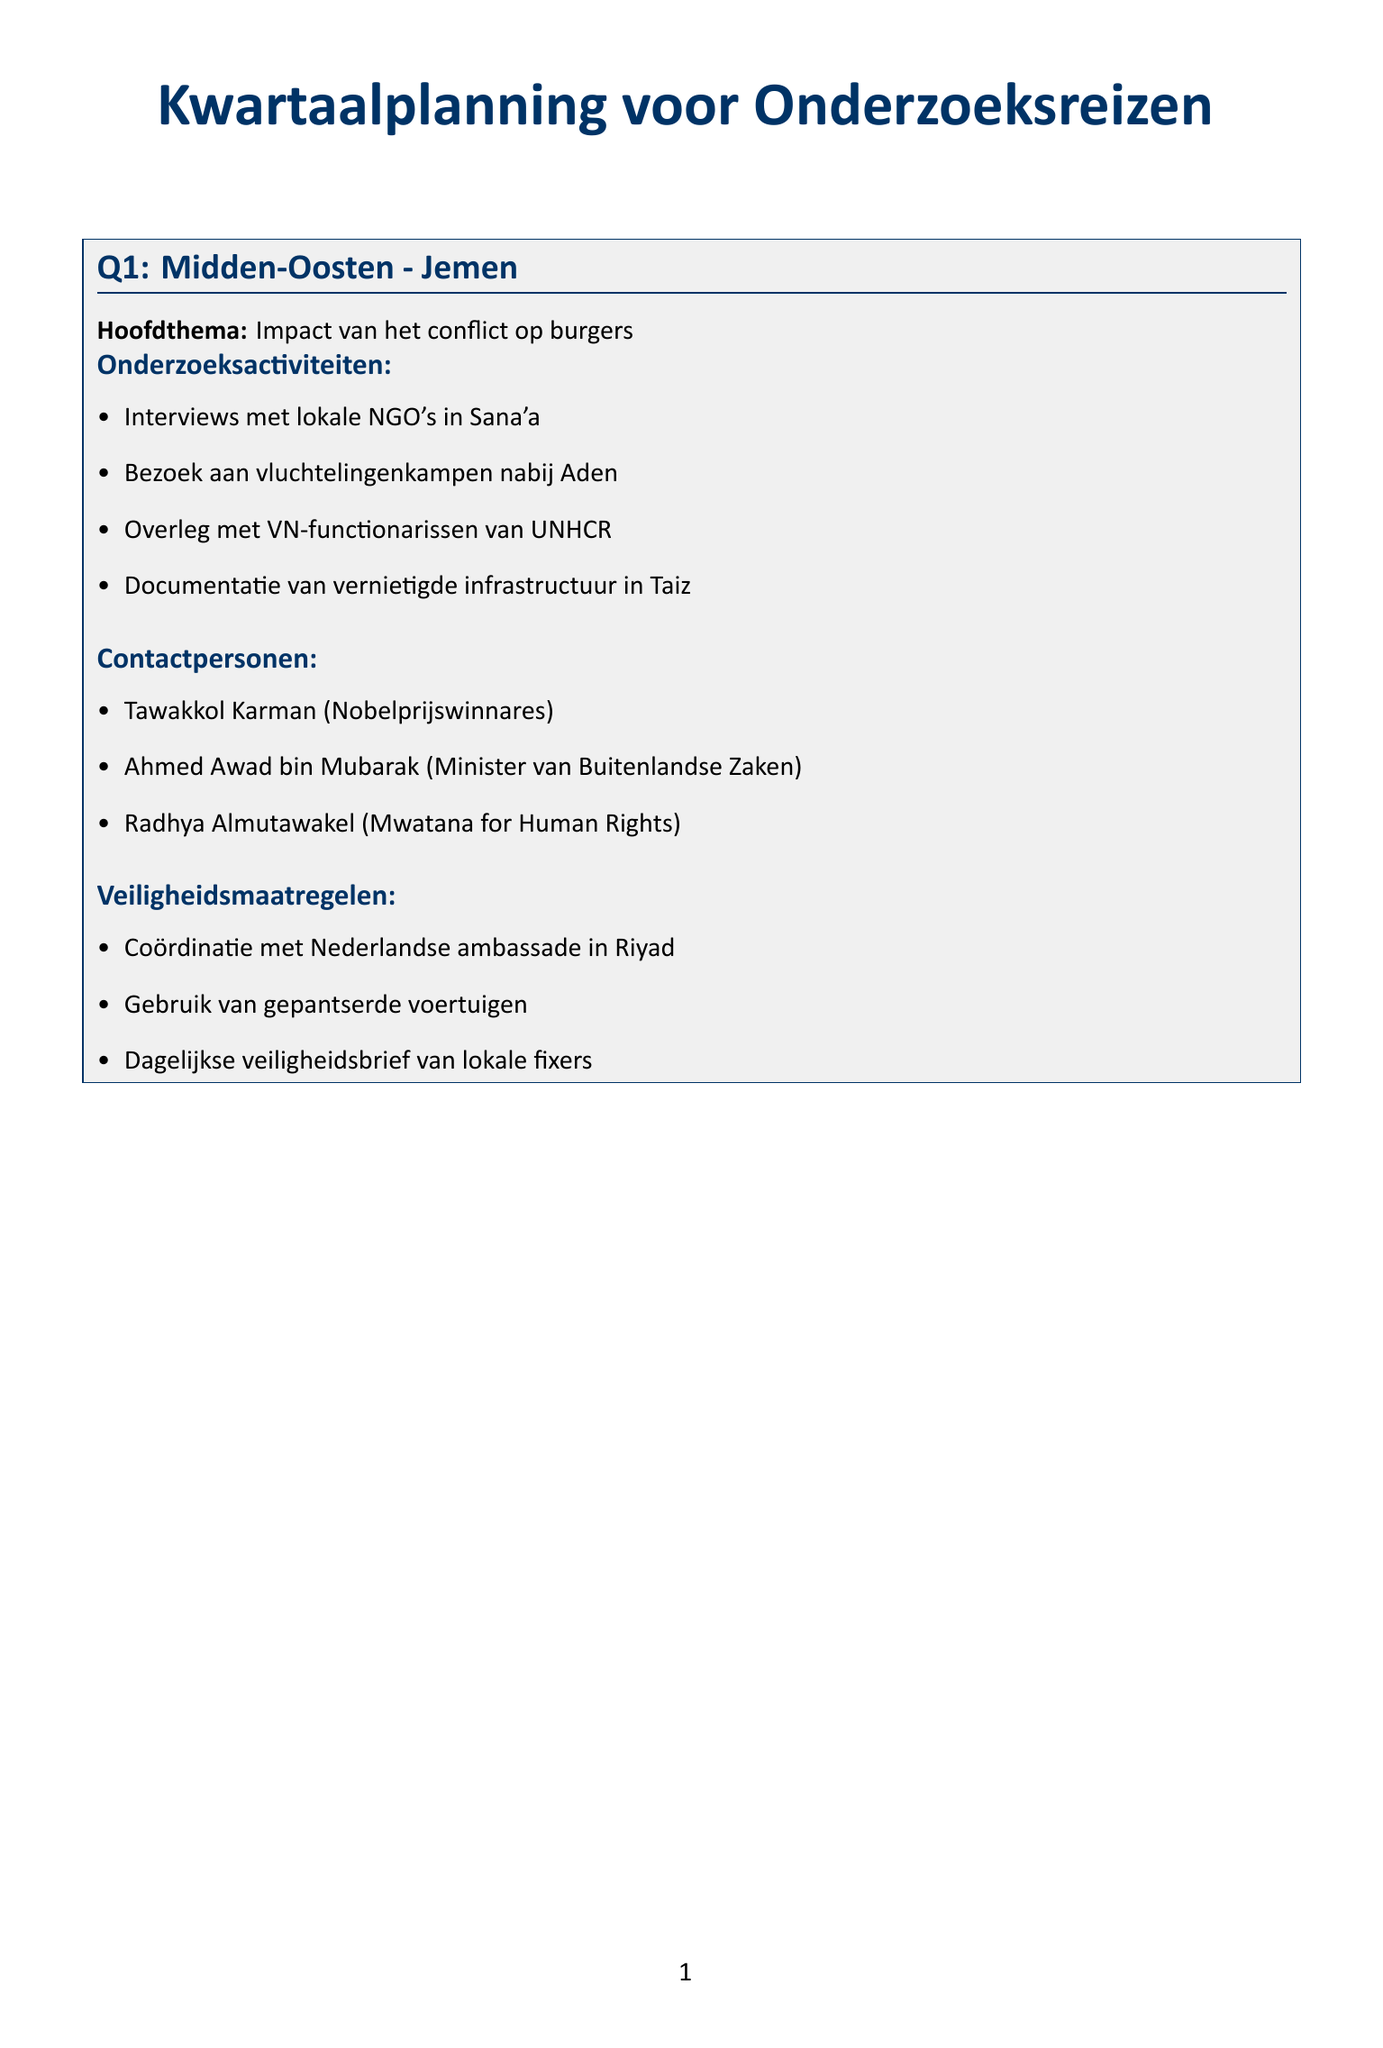wat is het hoofdthema van Q1? Het hoofdthema van Q1 is de impact van het conflict op burgers in Jemen.
Answer: Impact van het conflict op burgers hoeveel onderzoeksactiviteiten zijn er voor Q3? In Q3 zijn er vier onderzoeksactiviteiten vermeld voor Ethiopië.
Answer: 4 wie is de contactpersoon voor de VN-gezant voor seksueel geweld in conflicten in Q3? De contactpersoon is Pramila Patten, die de rol van VN-gezant voor seksueel geweld in conflicten vervult.
Answer: Pramila Patten welke veiligheidsmaatregel wordt genoemd voor Q4? Een veiligheidsmaatregel in Q4 is het gebruik van lokale fixers voor veilige routes.
Answer: Gebruik van lokale fixers voor veilige routes wat is de focusland van Q2? Het focusland van Q2 is Myanmar.
Answer: Myanmar welk onderwerp wordt besproken in Q3? Het onderwerp dat in Q3 wordt besproken is etnisch geweld en humanitaire crisis in Tigray.
Answer: Etnisch geweld en humanitaire crisis in Tigray met welke organisatie moet er in Q4 samengewerkt worden? In Q4 moet er samengewerkt worden met Foro Penal, een mensenrechtenorganisatie.
Answer: Foro Penal wat is een van de activiteiten die gepland zijn voor Q1? Een van de activiteiten die gepland zijn voor Q1 is het doen van interviews met lokale NGO's in Sana'a.
Answer: Interviews met lokale NGO's in Sana'a 